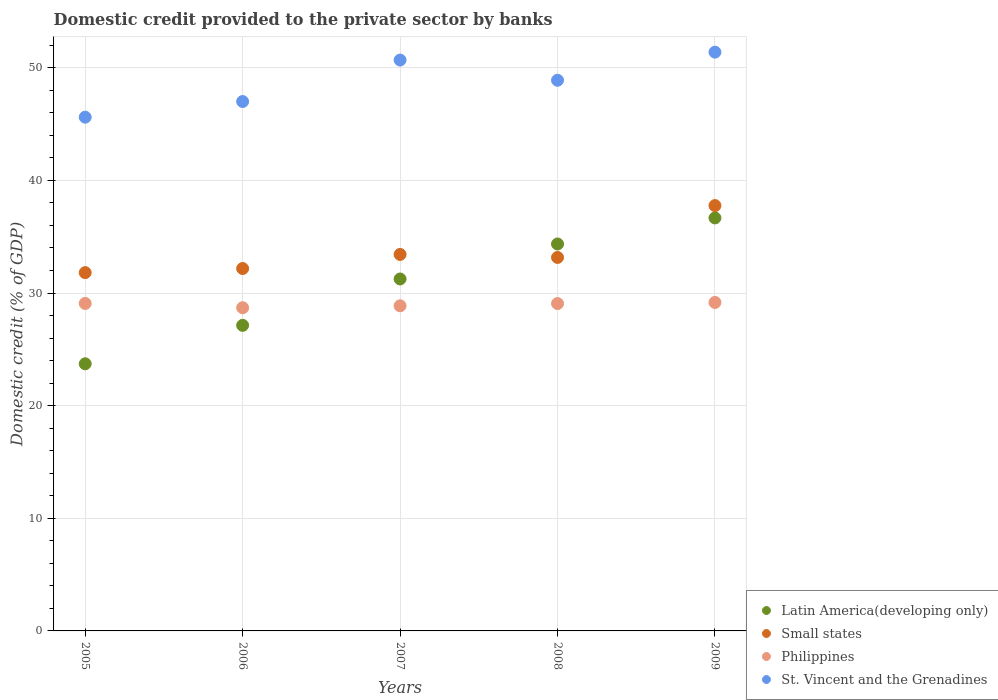How many different coloured dotlines are there?
Your answer should be compact. 4. What is the domestic credit provided to the private sector by banks in Small states in 2006?
Your response must be concise. 32.18. Across all years, what is the maximum domestic credit provided to the private sector by banks in St. Vincent and the Grenadines?
Your answer should be compact. 51.38. Across all years, what is the minimum domestic credit provided to the private sector by banks in Philippines?
Provide a short and direct response. 28.69. In which year was the domestic credit provided to the private sector by banks in St. Vincent and the Grenadines minimum?
Your response must be concise. 2005. What is the total domestic credit provided to the private sector by banks in Philippines in the graph?
Your response must be concise. 144.86. What is the difference between the domestic credit provided to the private sector by banks in St. Vincent and the Grenadines in 2006 and that in 2008?
Keep it short and to the point. -1.89. What is the difference between the domestic credit provided to the private sector by banks in Small states in 2008 and the domestic credit provided to the private sector by banks in St. Vincent and the Grenadines in 2009?
Provide a succinct answer. -18.23. What is the average domestic credit provided to the private sector by banks in Philippines per year?
Keep it short and to the point. 28.97. In the year 2009, what is the difference between the domestic credit provided to the private sector by banks in Small states and domestic credit provided to the private sector by banks in Latin America(developing only)?
Give a very brief answer. 1.1. What is the ratio of the domestic credit provided to the private sector by banks in Small states in 2006 to that in 2009?
Offer a terse response. 0.85. Is the domestic credit provided to the private sector by banks in Small states in 2006 less than that in 2009?
Make the answer very short. Yes. What is the difference between the highest and the second highest domestic credit provided to the private sector by banks in St. Vincent and the Grenadines?
Provide a short and direct response. 0.7. What is the difference between the highest and the lowest domestic credit provided to the private sector by banks in Philippines?
Make the answer very short. 0.47. Is the sum of the domestic credit provided to the private sector by banks in Small states in 2006 and 2007 greater than the maximum domestic credit provided to the private sector by banks in St. Vincent and the Grenadines across all years?
Make the answer very short. Yes. Is it the case that in every year, the sum of the domestic credit provided to the private sector by banks in St. Vincent and the Grenadines and domestic credit provided to the private sector by banks in Latin America(developing only)  is greater than the sum of domestic credit provided to the private sector by banks in Small states and domestic credit provided to the private sector by banks in Philippines?
Provide a succinct answer. Yes. Is it the case that in every year, the sum of the domestic credit provided to the private sector by banks in Philippines and domestic credit provided to the private sector by banks in Small states  is greater than the domestic credit provided to the private sector by banks in St. Vincent and the Grenadines?
Keep it short and to the point. Yes. Is the domestic credit provided to the private sector by banks in St. Vincent and the Grenadines strictly greater than the domestic credit provided to the private sector by banks in Philippines over the years?
Offer a terse response. Yes. What is the difference between two consecutive major ticks on the Y-axis?
Provide a succinct answer. 10. Are the values on the major ticks of Y-axis written in scientific E-notation?
Your answer should be very brief. No. Does the graph contain any zero values?
Make the answer very short. No. How many legend labels are there?
Your answer should be very brief. 4. What is the title of the graph?
Provide a succinct answer. Domestic credit provided to the private sector by banks. Does "Vanuatu" appear as one of the legend labels in the graph?
Your answer should be compact. No. What is the label or title of the Y-axis?
Give a very brief answer. Domestic credit (% of GDP). What is the Domestic credit (% of GDP) in Latin America(developing only) in 2005?
Give a very brief answer. 23.72. What is the Domestic credit (% of GDP) of Small states in 2005?
Your answer should be compact. 31.81. What is the Domestic credit (% of GDP) in Philippines in 2005?
Give a very brief answer. 29.07. What is the Domestic credit (% of GDP) in St. Vincent and the Grenadines in 2005?
Provide a succinct answer. 45.61. What is the Domestic credit (% of GDP) in Latin America(developing only) in 2006?
Keep it short and to the point. 27.13. What is the Domestic credit (% of GDP) of Small states in 2006?
Ensure brevity in your answer.  32.18. What is the Domestic credit (% of GDP) in Philippines in 2006?
Keep it short and to the point. 28.69. What is the Domestic credit (% of GDP) of St. Vincent and the Grenadines in 2006?
Offer a terse response. 47. What is the Domestic credit (% of GDP) in Latin America(developing only) in 2007?
Offer a terse response. 31.25. What is the Domestic credit (% of GDP) of Small states in 2007?
Make the answer very short. 33.43. What is the Domestic credit (% of GDP) in Philippines in 2007?
Your response must be concise. 28.86. What is the Domestic credit (% of GDP) in St. Vincent and the Grenadines in 2007?
Your response must be concise. 50.68. What is the Domestic credit (% of GDP) of Latin America(developing only) in 2008?
Provide a succinct answer. 34.35. What is the Domestic credit (% of GDP) in Small states in 2008?
Ensure brevity in your answer.  33.16. What is the Domestic credit (% of GDP) in Philippines in 2008?
Provide a short and direct response. 29.06. What is the Domestic credit (% of GDP) of St. Vincent and the Grenadines in 2008?
Offer a terse response. 48.89. What is the Domestic credit (% of GDP) of Latin America(developing only) in 2009?
Make the answer very short. 36.67. What is the Domestic credit (% of GDP) of Small states in 2009?
Your answer should be very brief. 37.76. What is the Domestic credit (% of GDP) of Philippines in 2009?
Ensure brevity in your answer.  29.16. What is the Domestic credit (% of GDP) in St. Vincent and the Grenadines in 2009?
Make the answer very short. 51.38. Across all years, what is the maximum Domestic credit (% of GDP) of Latin America(developing only)?
Make the answer very short. 36.67. Across all years, what is the maximum Domestic credit (% of GDP) of Small states?
Ensure brevity in your answer.  37.76. Across all years, what is the maximum Domestic credit (% of GDP) in Philippines?
Ensure brevity in your answer.  29.16. Across all years, what is the maximum Domestic credit (% of GDP) in St. Vincent and the Grenadines?
Offer a very short reply. 51.38. Across all years, what is the minimum Domestic credit (% of GDP) in Latin America(developing only)?
Offer a very short reply. 23.72. Across all years, what is the minimum Domestic credit (% of GDP) in Small states?
Offer a very short reply. 31.81. Across all years, what is the minimum Domestic credit (% of GDP) in Philippines?
Your response must be concise. 28.69. Across all years, what is the minimum Domestic credit (% of GDP) of St. Vincent and the Grenadines?
Keep it short and to the point. 45.61. What is the total Domestic credit (% of GDP) of Latin America(developing only) in the graph?
Make the answer very short. 153.11. What is the total Domestic credit (% of GDP) in Small states in the graph?
Offer a terse response. 168.33. What is the total Domestic credit (% of GDP) in Philippines in the graph?
Provide a short and direct response. 144.86. What is the total Domestic credit (% of GDP) in St. Vincent and the Grenadines in the graph?
Provide a succinct answer. 243.57. What is the difference between the Domestic credit (% of GDP) of Latin America(developing only) in 2005 and that in 2006?
Offer a very short reply. -3.41. What is the difference between the Domestic credit (% of GDP) in Small states in 2005 and that in 2006?
Provide a short and direct response. -0.36. What is the difference between the Domestic credit (% of GDP) of Philippines in 2005 and that in 2006?
Offer a terse response. 0.38. What is the difference between the Domestic credit (% of GDP) in St. Vincent and the Grenadines in 2005 and that in 2006?
Offer a terse response. -1.39. What is the difference between the Domestic credit (% of GDP) in Latin America(developing only) in 2005 and that in 2007?
Offer a very short reply. -7.53. What is the difference between the Domestic credit (% of GDP) in Small states in 2005 and that in 2007?
Offer a terse response. -1.61. What is the difference between the Domestic credit (% of GDP) in Philippines in 2005 and that in 2007?
Offer a very short reply. 0.21. What is the difference between the Domestic credit (% of GDP) in St. Vincent and the Grenadines in 2005 and that in 2007?
Offer a very short reply. -5.07. What is the difference between the Domestic credit (% of GDP) in Latin America(developing only) in 2005 and that in 2008?
Provide a succinct answer. -10.64. What is the difference between the Domestic credit (% of GDP) in Small states in 2005 and that in 2008?
Your answer should be compact. -1.35. What is the difference between the Domestic credit (% of GDP) in Philippines in 2005 and that in 2008?
Offer a very short reply. 0.01. What is the difference between the Domestic credit (% of GDP) of St. Vincent and the Grenadines in 2005 and that in 2008?
Ensure brevity in your answer.  -3.28. What is the difference between the Domestic credit (% of GDP) in Latin America(developing only) in 2005 and that in 2009?
Give a very brief answer. -12.95. What is the difference between the Domestic credit (% of GDP) in Small states in 2005 and that in 2009?
Your response must be concise. -5.95. What is the difference between the Domestic credit (% of GDP) in Philippines in 2005 and that in 2009?
Keep it short and to the point. -0.09. What is the difference between the Domestic credit (% of GDP) of St. Vincent and the Grenadines in 2005 and that in 2009?
Keep it short and to the point. -5.77. What is the difference between the Domestic credit (% of GDP) in Latin America(developing only) in 2006 and that in 2007?
Your response must be concise. -4.12. What is the difference between the Domestic credit (% of GDP) of Small states in 2006 and that in 2007?
Your answer should be compact. -1.25. What is the difference between the Domestic credit (% of GDP) in Philippines in 2006 and that in 2007?
Your response must be concise. -0.17. What is the difference between the Domestic credit (% of GDP) of St. Vincent and the Grenadines in 2006 and that in 2007?
Offer a very short reply. -3.68. What is the difference between the Domestic credit (% of GDP) in Latin America(developing only) in 2006 and that in 2008?
Your answer should be very brief. -7.22. What is the difference between the Domestic credit (% of GDP) in Small states in 2006 and that in 2008?
Make the answer very short. -0.98. What is the difference between the Domestic credit (% of GDP) of Philippines in 2006 and that in 2008?
Give a very brief answer. -0.37. What is the difference between the Domestic credit (% of GDP) in St. Vincent and the Grenadines in 2006 and that in 2008?
Provide a short and direct response. -1.89. What is the difference between the Domestic credit (% of GDP) of Latin America(developing only) in 2006 and that in 2009?
Give a very brief answer. -9.54. What is the difference between the Domestic credit (% of GDP) in Small states in 2006 and that in 2009?
Your answer should be very brief. -5.59. What is the difference between the Domestic credit (% of GDP) of Philippines in 2006 and that in 2009?
Your response must be concise. -0.47. What is the difference between the Domestic credit (% of GDP) of St. Vincent and the Grenadines in 2006 and that in 2009?
Keep it short and to the point. -4.38. What is the difference between the Domestic credit (% of GDP) of Latin America(developing only) in 2007 and that in 2008?
Give a very brief answer. -3.11. What is the difference between the Domestic credit (% of GDP) in Small states in 2007 and that in 2008?
Make the answer very short. 0.27. What is the difference between the Domestic credit (% of GDP) of Philippines in 2007 and that in 2008?
Your answer should be very brief. -0.2. What is the difference between the Domestic credit (% of GDP) in St. Vincent and the Grenadines in 2007 and that in 2008?
Keep it short and to the point. 1.79. What is the difference between the Domestic credit (% of GDP) in Latin America(developing only) in 2007 and that in 2009?
Make the answer very short. -5.42. What is the difference between the Domestic credit (% of GDP) in Small states in 2007 and that in 2009?
Offer a terse response. -4.34. What is the difference between the Domestic credit (% of GDP) in Philippines in 2007 and that in 2009?
Provide a short and direct response. -0.3. What is the difference between the Domestic credit (% of GDP) in St. Vincent and the Grenadines in 2007 and that in 2009?
Offer a terse response. -0.7. What is the difference between the Domestic credit (% of GDP) in Latin America(developing only) in 2008 and that in 2009?
Give a very brief answer. -2.31. What is the difference between the Domestic credit (% of GDP) of Small states in 2008 and that in 2009?
Offer a terse response. -4.6. What is the difference between the Domestic credit (% of GDP) in Philippines in 2008 and that in 2009?
Offer a very short reply. -0.1. What is the difference between the Domestic credit (% of GDP) in St. Vincent and the Grenadines in 2008 and that in 2009?
Offer a terse response. -2.49. What is the difference between the Domestic credit (% of GDP) in Latin America(developing only) in 2005 and the Domestic credit (% of GDP) in Small states in 2006?
Give a very brief answer. -8.46. What is the difference between the Domestic credit (% of GDP) in Latin America(developing only) in 2005 and the Domestic credit (% of GDP) in Philippines in 2006?
Your answer should be very brief. -4.98. What is the difference between the Domestic credit (% of GDP) in Latin America(developing only) in 2005 and the Domestic credit (% of GDP) in St. Vincent and the Grenadines in 2006?
Your response must be concise. -23.28. What is the difference between the Domestic credit (% of GDP) in Small states in 2005 and the Domestic credit (% of GDP) in Philippines in 2006?
Provide a succinct answer. 3.12. What is the difference between the Domestic credit (% of GDP) of Small states in 2005 and the Domestic credit (% of GDP) of St. Vincent and the Grenadines in 2006?
Your answer should be compact. -15.19. What is the difference between the Domestic credit (% of GDP) of Philippines in 2005 and the Domestic credit (% of GDP) of St. Vincent and the Grenadines in 2006?
Make the answer very short. -17.93. What is the difference between the Domestic credit (% of GDP) in Latin America(developing only) in 2005 and the Domestic credit (% of GDP) in Small states in 2007?
Offer a terse response. -9.71. What is the difference between the Domestic credit (% of GDP) of Latin America(developing only) in 2005 and the Domestic credit (% of GDP) of Philippines in 2007?
Offer a very short reply. -5.15. What is the difference between the Domestic credit (% of GDP) of Latin America(developing only) in 2005 and the Domestic credit (% of GDP) of St. Vincent and the Grenadines in 2007?
Provide a succinct answer. -26.97. What is the difference between the Domestic credit (% of GDP) in Small states in 2005 and the Domestic credit (% of GDP) in Philippines in 2007?
Your answer should be compact. 2.95. What is the difference between the Domestic credit (% of GDP) of Small states in 2005 and the Domestic credit (% of GDP) of St. Vincent and the Grenadines in 2007?
Your answer should be very brief. -18.87. What is the difference between the Domestic credit (% of GDP) of Philippines in 2005 and the Domestic credit (% of GDP) of St. Vincent and the Grenadines in 2007?
Offer a terse response. -21.61. What is the difference between the Domestic credit (% of GDP) of Latin America(developing only) in 2005 and the Domestic credit (% of GDP) of Small states in 2008?
Ensure brevity in your answer.  -9.44. What is the difference between the Domestic credit (% of GDP) in Latin America(developing only) in 2005 and the Domestic credit (% of GDP) in Philippines in 2008?
Offer a terse response. -5.35. What is the difference between the Domestic credit (% of GDP) of Latin America(developing only) in 2005 and the Domestic credit (% of GDP) of St. Vincent and the Grenadines in 2008?
Your answer should be compact. -25.17. What is the difference between the Domestic credit (% of GDP) in Small states in 2005 and the Domestic credit (% of GDP) in Philippines in 2008?
Keep it short and to the point. 2.75. What is the difference between the Domestic credit (% of GDP) in Small states in 2005 and the Domestic credit (% of GDP) in St. Vincent and the Grenadines in 2008?
Give a very brief answer. -17.08. What is the difference between the Domestic credit (% of GDP) of Philippines in 2005 and the Domestic credit (% of GDP) of St. Vincent and the Grenadines in 2008?
Keep it short and to the point. -19.82. What is the difference between the Domestic credit (% of GDP) of Latin America(developing only) in 2005 and the Domestic credit (% of GDP) of Small states in 2009?
Make the answer very short. -14.05. What is the difference between the Domestic credit (% of GDP) in Latin America(developing only) in 2005 and the Domestic credit (% of GDP) in Philippines in 2009?
Keep it short and to the point. -5.45. What is the difference between the Domestic credit (% of GDP) of Latin America(developing only) in 2005 and the Domestic credit (% of GDP) of St. Vincent and the Grenadines in 2009?
Offer a terse response. -27.67. What is the difference between the Domestic credit (% of GDP) in Small states in 2005 and the Domestic credit (% of GDP) in Philippines in 2009?
Ensure brevity in your answer.  2.65. What is the difference between the Domestic credit (% of GDP) in Small states in 2005 and the Domestic credit (% of GDP) in St. Vincent and the Grenadines in 2009?
Your answer should be compact. -19.57. What is the difference between the Domestic credit (% of GDP) of Philippines in 2005 and the Domestic credit (% of GDP) of St. Vincent and the Grenadines in 2009?
Offer a terse response. -22.31. What is the difference between the Domestic credit (% of GDP) of Latin America(developing only) in 2006 and the Domestic credit (% of GDP) of Small states in 2007?
Your response must be concise. -6.3. What is the difference between the Domestic credit (% of GDP) of Latin America(developing only) in 2006 and the Domestic credit (% of GDP) of Philippines in 2007?
Your answer should be very brief. -1.73. What is the difference between the Domestic credit (% of GDP) in Latin America(developing only) in 2006 and the Domestic credit (% of GDP) in St. Vincent and the Grenadines in 2007?
Make the answer very short. -23.55. What is the difference between the Domestic credit (% of GDP) in Small states in 2006 and the Domestic credit (% of GDP) in Philippines in 2007?
Your answer should be very brief. 3.31. What is the difference between the Domestic credit (% of GDP) in Small states in 2006 and the Domestic credit (% of GDP) in St. Vincent and the Grenadines in 2007?
Your response must be concise. -18.51. What is the difference between the Domestic credit (% of GDP) of Philippines in 2006 and the Domestic credit (% of GDP) of St. Vincent and the Grenadines in 2007?
Your response must be concise. -21.99. What is the difference between the Domestic credit (% of GDP) of Latin America(developing only) in 2006 and the Domestic credit (% of GDP) of Small states in 2008?
Your answer should be very brief. -6.03. What is the difference between the Domestic credit (% of GDP) in Latin America(developing only) in 2006 and the Domestic credit (% of GDP) in Philippines in 2008?
Your response must be concise. -1.94. What is the difference between the Domestic credit (% of GDP) of Latin America(developing only) in 2006 and the Domestic credit (% of GDP) of St. Vincent and the Grenadines in 2008?
Provide a short and direct response. -21.76. What is the difference between the Domestic credit (% of GDP) in Small states in 2006 and the Domestic credit (% of GDP) in Philippines in 2008?
Offer a terse response. 3.11. What is the difference between the Domestic credit (% of GDP) in Small states in 2006 and the Domestic credit (% of GDP) in St. Vincent and the Grenadines in 2008?
Provide a short and direct response. -16.71. What is the difference between the Domestic credit (% of GDP) of Philippines in 2006 and the Domestic credit (% of GDP) of St. Vincent and the Grenadines in 2008?
Your answer should be compact. -20.2. What is the difference between the Domestic credit (% of GDP) in Latin America(developing only) in 2006 and the Domestic credit (% of GDP) in Small states in 2009?
Offer a terse response. -10.63. What is the difference between the Domestic credit (% of GDP) in Latin America(developing only) in 2006 and the Domestic credit (% of GDP) in Philippines in 2009?
Provide a short and direct response. -2.03. What is the difference between the Domestic credit (% of GDP) in Latin America(developing only) in 2006 and the Domestic credit (% of GDP) in St. Vincent and the Grenadines in 2009?
Ensure brevity in your answer.  -24.26. What is the difference between the Domestic credit (% of GDP) of Small states in 2006 and the Domestic credit (% of GDP) of Philippines in 2009?
Give a very brief answer. 3.01. What is the difference between the Domestic credit (% of GDP) in Small states in 2006 and the Domestic credit (% of GDP) in St. Vincent and the Grenadines in 2009?
Make the answer very short. -19.21. What is the difference between the Domestic credit (% of GDP) of Philippines in 2006 and the Domestic credit (% of GDP) of St. Vincent and the Grenadines in 2009?
Offer a very short reply. -22.69. What is the difference between the Domestic credit (% of GDP) in Latin America(developing only) in 2007 and the Domestic credit (% of GDP) in Small states in 2008?
Your response must be concise. -1.91. What is the difference between the Domestic credit (% of GDP) of Latin America(developing only) in 2007 and the Domestic credit (% of GDP) of Philippines in 2008?
Your answer should be very brief. 2.18. What is the difference between the Domestic credit (% of GDP) of Latin America(developing only) in 2007 and the Domestic credit (% of GDP) of St. Vincent and the Grenadines in 2008?
Make the answer very short. -17.64. What is the difference between the Domestic credit (% of GDP) in Small states in 2007 and the Domestic credit (% of GDP) in Philippines in 2008?
Offer a very short reply. 4.36. What is the difference between the Domestic credit (% of GDP) of Small states in 2007 and the Domestic credit (% of GDP) of St. Vincent and the Grenadines in 2008?
Your response must be concise. -15.46. What is the difference between the Domestic credit (% of GDP) of Philippines in 2007 and the Domestic credit (% of GDP) of St. Vincent and the Grenadines in 2008?
Your answer should be compact. -20.03. What is the difference between the Domestic credit (% of GDP) in Latin America(developing only) in 2007 and the Domestic credit (% of GDP) in Small states in 2009?
Provide a short and direct response. -6.51. What is the difference between the Domestic credit (% of GDP) in Latin America(developing only) in 2007 and the Domestic credit (% of GDP) in Philippines in 2009?
Keep it short and to the point. 2.08. What is the difference between the Domestic credit (% of GDP) of Latin America(developing only) in 2007 and the Domestic credit (% of GDP) of St. Vincent and the Grenadines in 2009?
Your answer should be very brief. -20.14. What is the difference between the Domestic credit (% of GDP) in Small states in 2007 and the Domestic credit (% of GDP) in Philippines in 2009?
Ensure brevity in your answer.  4.26. What is the difference between the Domestic credit (% of GDP) in Small states in 2007 and the Domestic credit (% of GDP) in St. Vincent and the Grenadines in 2009?
Make the answer very short. -17.96. What is the difference between the Domestic credit (% of GDP) in Philippines in 2007 and the Domestic credit (% of GDP) in St. Vincent and the Grenadines in 2009?
Keep it short and to the point. -22.52. What is the difference between the Domestic credit (% of GDP) of Latin America(developing only) in 2008 and the Domestic credit (% of GDP) of Small states in 2009?
Provide a short and direct response. -3.41. What is the difference between the Domestic credit (% of GDP) in Latin America(developing only) in 2008 and the Domestic credit (% of GDP) in Philippines in 2009?
Provide a short and direct response. 5.19. What is the difference between the Domestic credit (% of GDP) of Latin America(developing only) in 2008 and the Domestic credit (% of GDP) of St. Vincent and the Grenadines in 2009?
Offer a very short reply. -17.03. What is the difference between the Domestic credit (% of GDP) in Small states in 2008 and the Domestic credit (% of GDP) in Philippines in 2009?
Provide a succinct answer. 4. What is the difference between the Domestic credit (% of GDP) of Small states in 2008 and the Domestic credit (% of GDP) of St. Vincent and the Grenadines in 2009?
Ensure brevity in your answer.  -18.23. What is the difference between the Domestic credit (% of GDP) of Philippines in 2008 and the Domestic credit (% of GDP) of St. Vincent and the Grenadines in 2009?
Make the answer very short. -22.32. What is the average Domestic credit (% of GDP) of Latin America(developing only) per year?
Ensure brevity in your answer.  30.62. What is the average Domestic credit (% of GDP) in Small states per year?
Provide a short and direct response. 33.67. What is the average Domestic credit (% of GDP) of Philippines per year?
Provide a succinct answer. 28.97. What is the average Domestic credit (% of GDP) of St. Vincent and the Grenadines per year?
Offer a very short reply. 48.71. In the year 2005, what is the difference between the Domestic credit (% of GDP) of Latin America(developing only) and Domestic credit (% of GDP) of Small states?
Give a very brief answer. -8.09. In the year 2005, what is the difference between the Domestic credit (% of GDP) of Latin America(developing only) and Domestic credit (% of GDP) of Philippines?
Provide a short and direct response. -5.36. In the year 2005, what is the difference between the Domestic credit (% of GDP) in Latin America(developing only) and Domestic credit (% of GDP) in St. Vincent and the Grenadines?
Make the answer very short. -21.89. In the year 2005, what is the difference between the Domestic credit (% of GDP) of Small states and Domestic credit (% of GDP) of Philippines?
Ensure brevity in your answer.  2.74. In the year 2005, what is the difference between the Domestic credit (% of GDP) of Small states and Domestic credit (% of GDP) of St. Vincent and the Grenadines?
Provide a succinct answer. -13.8. In the year 2005, what is the difference between the Domestic credit (% of GDP) in Philippines and Domestic credit (% of GDP) in St. Vincent and the Grenadines?
Ensure brevity in your answer.  -16.54. In the year 2006, what is the difference between the Domestic credit (% of GDP) of Latin America(developing only) and Domestic credit (% of GDP) of Small states?
Give a very brief answer. -5.05. In the year 2006, what is the difference between the Domestic credit (% of GDP) in Latin America(developing only) and Domestic credit (% of GDP) in Philippines?
Ensure brevity in your answer.  -1.56. In the year 2006, what is the difference between the Domestic credit (% of GDP) in Latin America(developing only) and Domestic credit (% of GDP) in St. Vincent and the Grenadines?
Ensure brevity in your answer.  -19.87. In the year 2006, what is the difference between the Domestic credit (% of GDP) of Small states and Domestic credit (% of GDP) of Philippines?
Provide a short and direct response. 3.48. In the year 2006, what is the difference between the Domestic credit (% of GDP) in Small states and Domestic credit (% of GDP) in St. Vincent and the Grenadines?
Make the answer very short. -14.83. In the year 2006, what is the difference between the Domestic credit (% of GDP) of Philippines and Domestic credit (% of GDP) of St. Vincent and the Grenadines?
Make the answer very short. -18.31. In the year 2007, what is the difference between the Domestic credit (% of GDP) of Latin America(developing only) and Domestic credit (% of GDP) of Small states?
Offer a very short reply. -2.18. In the year 2007, what is the difference between the Domestic credit (% of GDP) in Latin America(developing only) and Domestic credit (% of GDP) in Philippines?
Your answer should be very brief. 2.38. In the year 2007, what is the difference between the Domestic credit (% of GDP) of Latin America(developing only) and Domestic credit (% of GDP) of St. Vincent and the Grenadines?
Your answer should be compact. -19.44. In the year 2007, what is the difference between the Domestic credit (% of GDP) of Small states and Domestic credit (% of GDP) of Philippines?
Ensure brevity in your answer.  4.56. In the year 2007, what is the difference between the Domestic credit (% of GDP) in Small states and Domestic credit (% of GDP) in St. Vincent and the Grenadines?
Your answer should be very brief. -17.26. In the year 2007, what is the difference between the Domestic credit (% of GDP) in Philippines and Domestic credit (% of GDP) in St. Vincent and the Grenadines?
Your answer should be very brief. -21.82. In the year 2008, what is the difference between the Domestic credit (% of GDP) in Latin America(developing only) and Domestic credit (% of GDP) in Small states?
Your answer should be compact. 1.19. In the year 2008, what is the difference between the Domestic credit (% of GDP) of Latin America(developing only) and Domestic credit (% of GDP) of Philippines?
Your answer should be compact. 5.29. In the year 2008, what is the difference between the Domestic credit (% of GDP) in Latin America(developing only) and Domestic credit (% of GDP) in St. Vincent and the Grenadines?
Offer a terse response. -14.54. In the year 2008, what is the difference between the Domestic credit (% of GDP) in Small states and Domestic credit (% of GDP) in Philippines?
Ensure brevity in your answer.  4.09. In the year 2008, what is the difference between the Domestic credit (% of GDP) of Small states and Domestic credit (% of GDP) of St. Vincent and the Grenadines?
Ensure brevity in your answer.  -15.73. In the year 2008, what is the difference between the Domestic credit (% of GDP) in Philippines and Domestic credit (% of GDP) in St. Vincent and the Grenadines?
Your response must be concise. -19.83. In the year 2009, what is the difference between the Domestic credit (% of GDP) in Latin America(developing only) and Domestic credit (% of GDP) in Small states?
Your answer should be compact. -1.1. In the year 2009, what is the difference between the Domestic credit (% of GDP) of Latin America(developing only) and Domestic credit (% of GDP) of Philippines?
Offer a terse response. 7.5. In the year 2009, what is the difference between the Domestic credit (% of GDP) in Latin America(developing only) and Domestic credit (% of GDP) in St. Vincent and the Grenadines?
Provide a succinct answer. -14.72. In the year 2009, what is the difference between the Domestic credit (% of GDP) in Small states and Domestic credit (% of GDP) in Philippines?
Ensure brevity in your answer.  8.6. In the year 2009, what is the difference between the Domestic credit (% of GDP) in Small states and Domestic credit (% of GDP) in St. Vincent and the Grenadines?
Provide a short and direct response. -13.62. In the year 2009, what is the difference between the Domestic credit (% of GDP) of Philippines and Domestic credit (% of GDP) of St. Vincent and the Grenadines?
Your response must be concise. -22.22. What is the ratio of the Domestic credit (% of GDP) in Latin America(developing only) in 2005 to that in 2006?
Offer a terse response. 0.87. What is the ratio of the Domestic credit (% of GDP) in Small states in 2005 to that in 2006?
Provide a succinct answer. 0.99. What is the ratio of the Domestic credit (% of GDP) of Philippines in 2005 to that in 2006?
Give a very brief answer. 1.01. What is the ratio of the Domestic credit (% of GDP) in St. Vincent and the Grenadines in 2005 to that in 2006?
Make the answer very short. 0.97. What is the ratio of the Domestic credit (% of GDP) in Latin America(developing only) in 2005 to that in 2007?
Your answer should be compact. 0.76. What is the ratio of the Domestic credit (% of GDP) in Small states in 2005 to that in 2007?
Keep it short and to the point. 0.95. What is the ratio of the Domestic credit (% of GDP) of Philippines in 2005 to that in 2007?
Provide a succinct answer. 1.01. What is the ratio of the Domestic credit (% of GDP) in St. Vincent and the Grenadines in 2005 to that in 2007?
Offer a very short reply. 0.9. What is the ratio of the Domestic credit (% of GDP) of Latin America(developing only) in 2005 to that in 2008?
Provide a short and direct response. 0.69. What is the ratio of the Domestic credit (% of GDP) in Small states in 2005 to that in 2008?
Your answer should be very brief. 0.96. What is the ratio of the Domestic credit (% of GDP) of St. Vincent and the Grenadines in 2005 to that in 2008?
Give a very brief answer. 0.93. What is the ratio of the Domestic credit (% of GDP) in Latin America(developing only) in 2005 to that in 2009?
Provide a short and direct response. 0.65. What is the ratio of the Domestic credit (% of GDP) in Small states in 2005 to that in 2009?
Your answer should be compact. 0.84. What is the ratio of the Domestic credit (% of GDP) of St. Vincent and the Grenadines in 2005 to that in 2009?
Keep it short and to the point. 0.89. What is the ratio of the Domestic credit (% of GDP) of Latin America(developing only) in 2006 to that in 2007?
Give a very brief answer. 0.87. What is the ratio of the Domestic credit (% of GDP) of Small states in 2006 to that in 2007?
Your response must be concise. 0.96. What is the ratio of the Domestic credit (% of GDP) of St. Vincent and the Grenadines in 2006 to that in 2007?
Make the answer very short. 0.93. What is the ratio of the Domestic credit (% of GDP) in Latin America(developing only) in 2006 to that in 2008?
Make the answer very short. 0.79. What is the ratio of the Domestic credit (% of GDP) of Small states in 2006 to that in 2008?
Keep it short and to the point. 0.97. What is the ratio of the Domestic credit (% of GDP) in Philippines in 2006 to that in 2008?
Your response must be concise. 0.99. What is the ratio of the Domestic credit (% of GDP) of St. Vincent and the Grenadines in 2006 to that in 2008?
Provide a succinct answer. 0.96. What is the ratio of the Domestic credit (% of GDP) in Latin America(developing only) in 2006 to that in 2009?
Your answer should be compact. 0.74. What is the ratio of the Domestic credit (% of GDP) of Small states in 2006 to that in 2009?
Your answer should be compact. 0.85. What is the ratio of the Domestic credit (% of GDP) of Philippines in 2006 to that in 2009?
Your response must be concise. 0.98. What is the ratio of the Domestic credit (% of GDP) of St. Vincent and the Grenadines in 2006 to that in 2009?
Make the answer very short. 0.91. What is the ratio of the Domestic credit (% of GDP) in Latin America(developing only) in 2007 to that in 2008?
Make the answer very short. 0.91. What is the ratio of the Domestic credit (% of GDP) of Small states in 2007 to that in 2008?
Give a very brief answer. 1.01. What is the ratio of the Domestic credit (% of GDP) of St. Vincent and the Grenadines in 2007 to that in 2008?
Ensure brevity in your answer.  1.04. What is the ratio of the Domestic credit (% of GDP) in Latin America(developing only) in 2007 to that in 2009?
Give a very brief answer. 0.85. What is the ratio of the Domestic credit (% of GDP) in Small states in 2007 to that in 2009?
Your answer should be compact. 0.89. What is the ratio of the Domestic credit (% of GDP) in Philippines in 2007 to that in 2009?
Provide a short and direct response. 0.99. What is the ratio of the Domestic credit (% of GDP) of St. Vincent and the Grenadines in 2007 to that in 2009?
Keep it short and to the point. 0.99. What is the ratio of the Domestic credit (% of GDP) of Latin America(developing only) in 2008 to that in 2009?
Your response must be concise. 0.94. What is the ratio of the Domestic credit (% of GDP) in Small states in 2008 to that in 2009?
Your response must be concise. 0.88. What is the ratio of the Domestic credit (% of GDP) in Philippines in 2008 to that in 2009?
Keep it short and to the point. 1. What is the ratio of the Domestic credit (% of GDP) in St. Vincent and the Grenadines in 2008 to that in 2009?
Your answer should be very brief. 0.95. What is the difference between the highest and the second highest Domestic credit (% of GDP) of Latin America(developing only)?
Provide a short and direct response. 2.31. What is the difference between the highest and the second highest Domestic credit (% of GDP) of Small states?
Make the answer very short. 4.34. What is the difference between the highest and the second highest Domestic credit (% of GDP) of Philippines?
Your answer should be very brief. 0.09. What is the difference between the highest and the second highest Domestic credit (% of GDP) of St. Vincent and the Grenadines?
Make the answer very short. 0.7. What is the difference between the highest and the lowest Domestic credit (% of GDP) of Latin America(developing only)?
Offer a terse response. 12.95. What is the difference between the highest and the lowest Domestic credit (% of GDP) in Small states?
Offer a very short reply. 5.95. What is the difference between the highest and the lowest Domestic credit (% of GDP) in Philippines?
Provide a succinct answer. 0.47. What is the difference between the highest and the lowest Domestic credit (% of GDP) of St. Vincent and the Grenadines?
Keep it short and to the point. 5.77. 